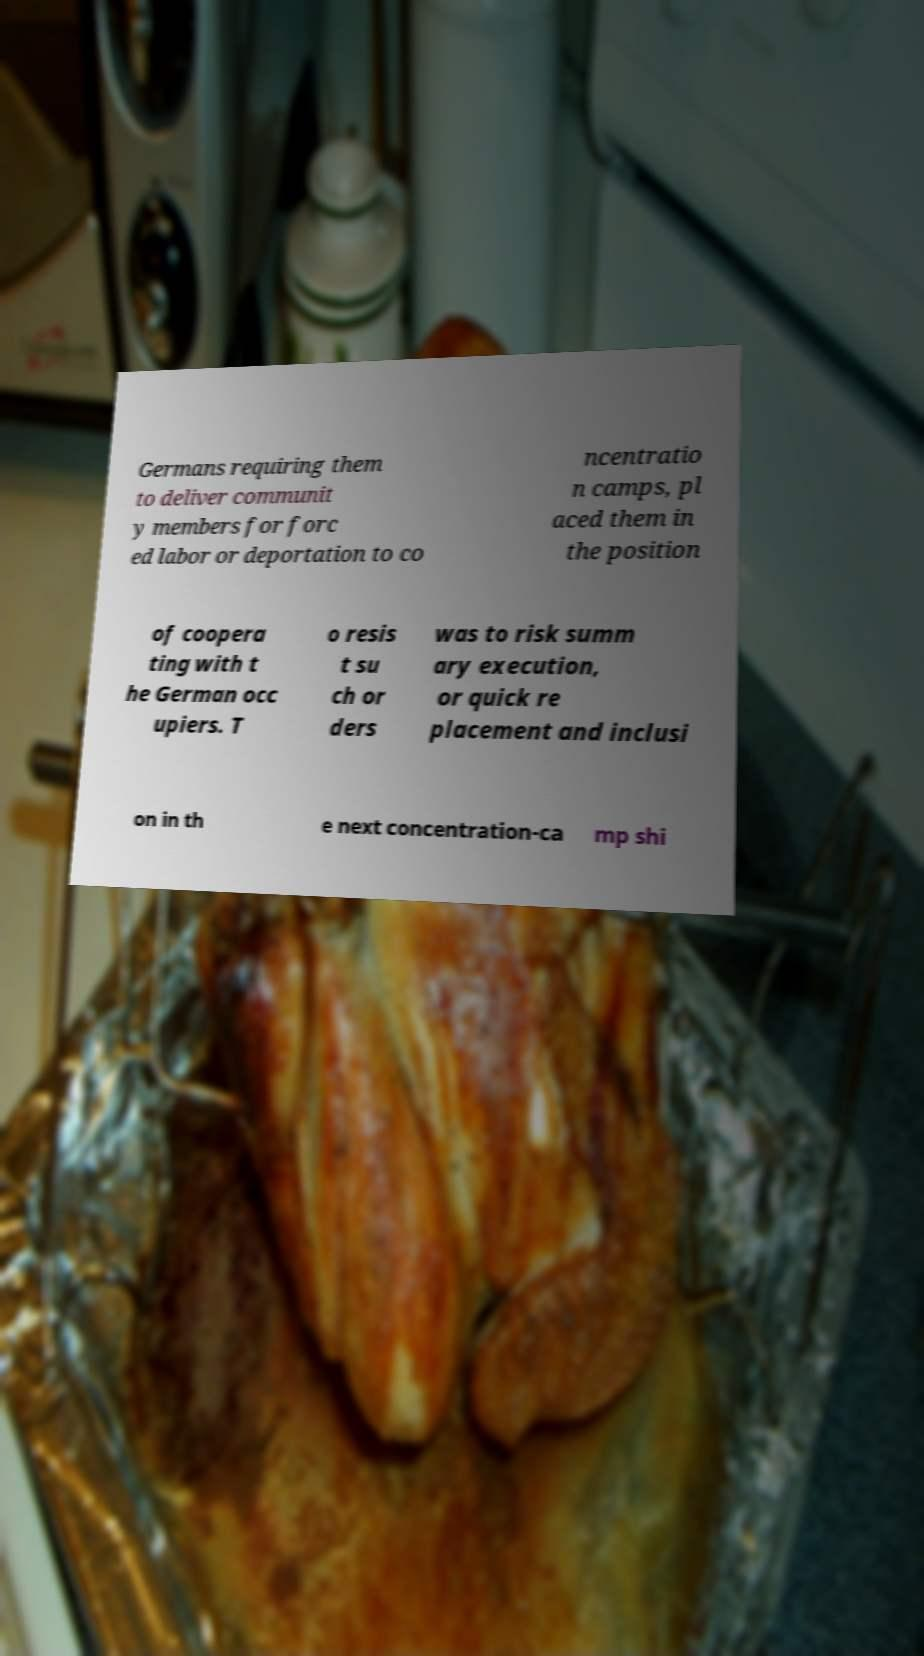There's text embedded in this image that I need extracted. Can you transcribe it verbatim? Germans requiring them to deliver communit y members for forc ed labor or deportation to co ncentratio n camps, pl aced them in the position of coopera ting with t he German occ upiers. T o resis t su ch or ders was to risk summ ary execution, or quick re placement and inclusi on in th e next concentration-ca mp shi 